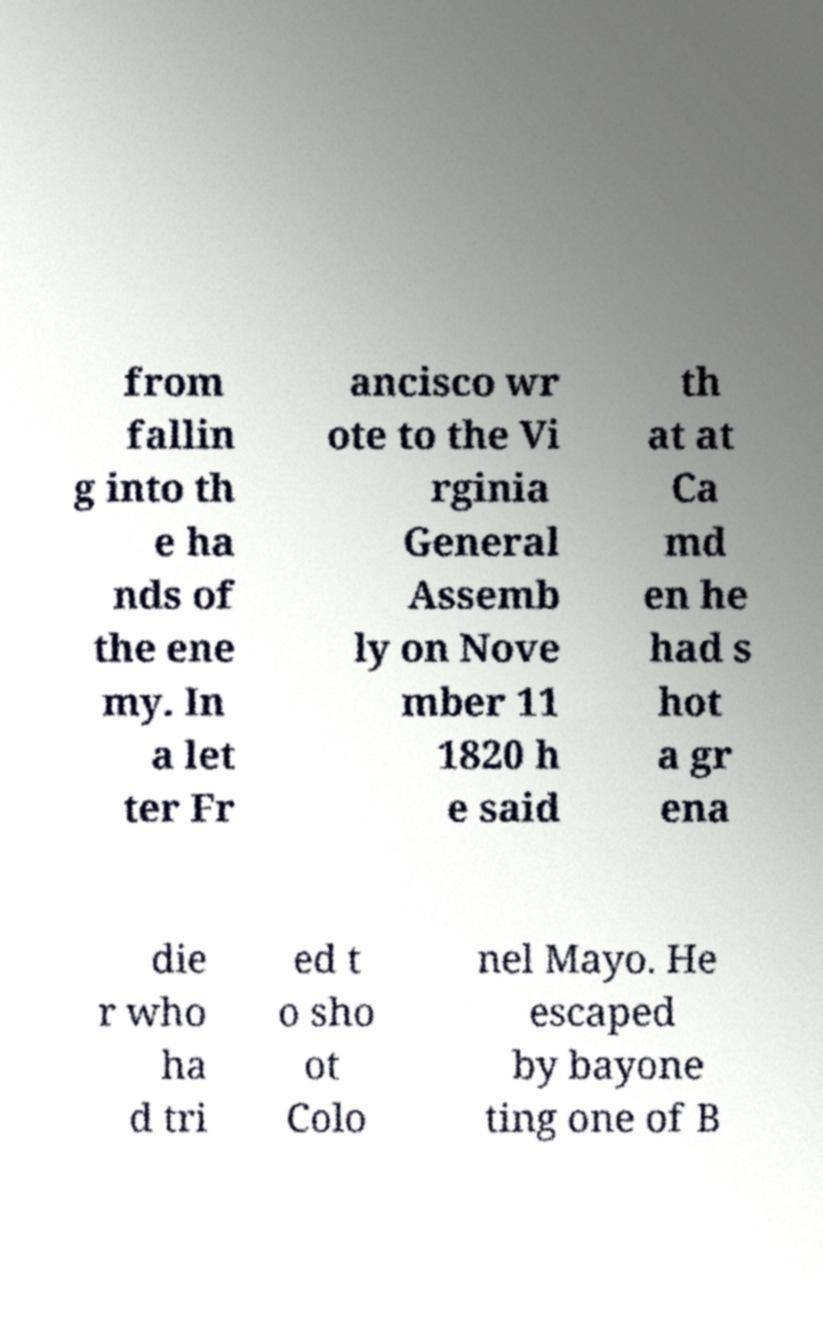What messages or text are displayed in this image? I need them in a readable, typed format. from fallin g into th e ha nds of the ene my. In a let ter Fr ancisco wr ote to the Vi rginia General Assemb ly on Nove mber 11 1820 h e said th at at Ca md en he had s hot a gr ena die r who ha d tri ed t o sho ot Colo nel Mayo. He escaped by bayone ting one of B 